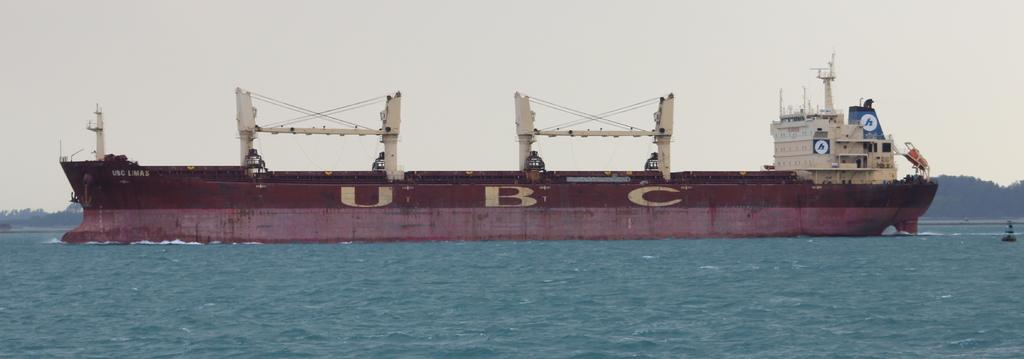What is the main subject of the image? The main subject of the image is a ship. Where is the ship located? The ship is on the water. What else can be seen in the image besides the ship? There are objects and trees in the background of the image. What is visible in the background of the image? The sky is visible in the background of the image. What type of flesh can be seen on the ship in the image? There is no flesh present on the ship in the image. What property is being sold in the image? There is no property being sold in the image; it features a ship on the water. 